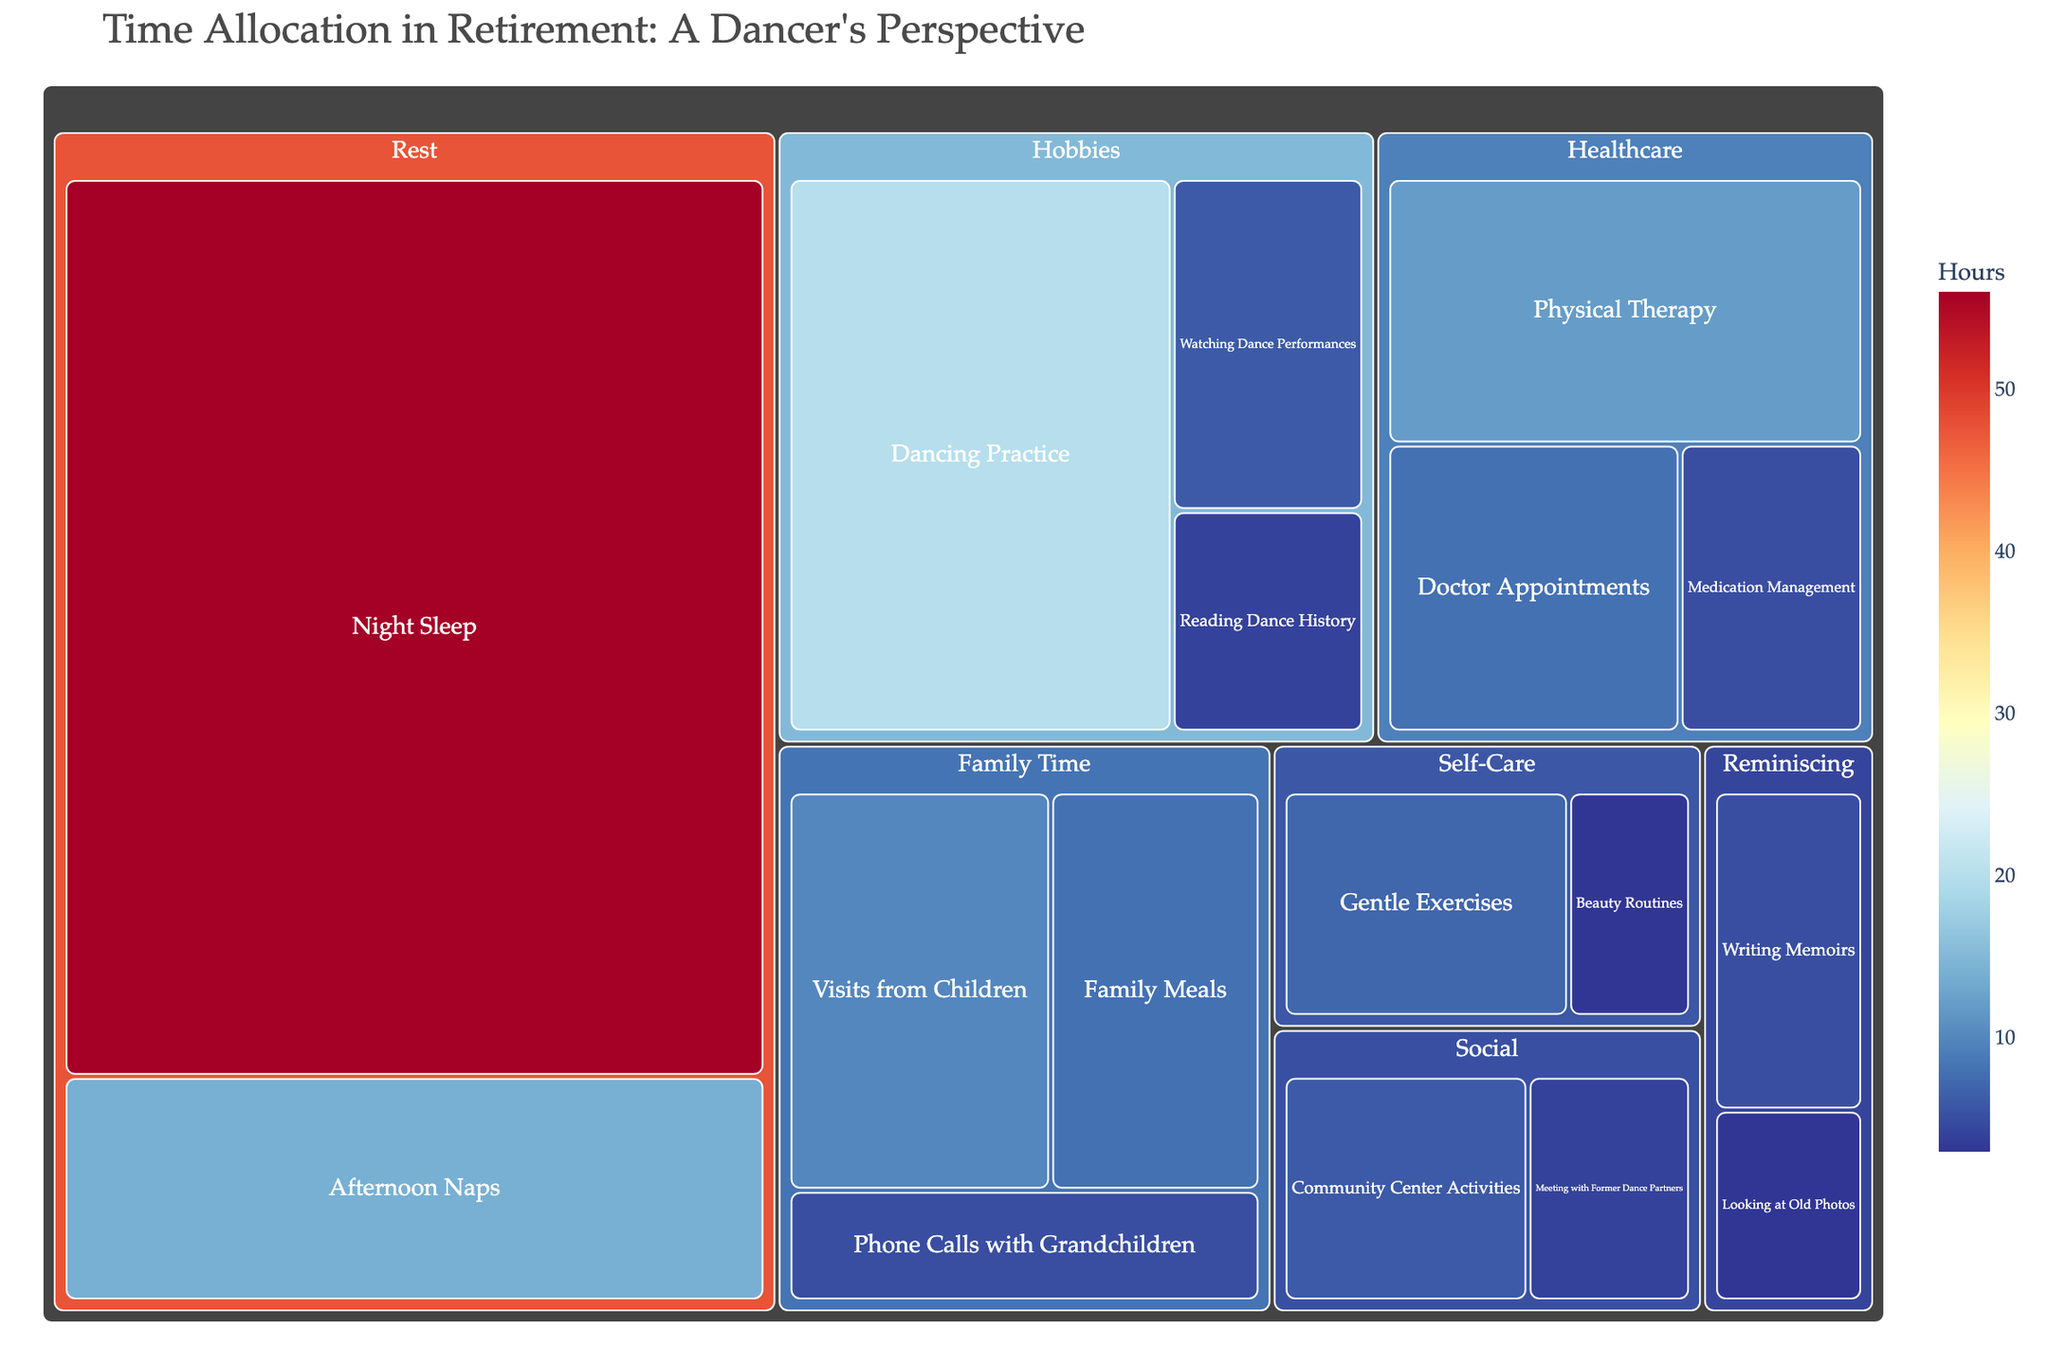What's the title of the figure? The title of the figure is provided at the top of the treemap.
Answer: Time Allocation in Retirement: A Dancer's Perspective Which subcategory under Healthcare has the highest hours? Check the Healthcare category and compare the hours of Doctor Appointments, Physical Therapy, and Medication Management.
Answer: Physical Therapy What is the total time spent on Hobbies? Sum the hours spent on Dancing Practice, Watching Dance Performances, and Reading Dance History. 20 + 6 + 4 = 30
Answer: 30 How does the time spent on Night Sleep compare to Family Meals? Compare the hours shown for Night Sleep and Family Meals to determine which is greater. Night Sleep has 56 hours and Family Meals has 8 hours.
Answer: Night Sleep is greater What is the average time spent on each activity in the Rest category? Sum the hours for Afternoon Naps and Night Sleep, then divide by the number of activities. (14 + 56) / 2 = 35
Answer: 35 Which category has the least amount of time allocated? Explain your reasoning. Compare the total hours for each category: Healthcare, Hobbies, Family Time, Rest, Reminiscing, Social, Self-Care and determine the smallest one.
Answer: Reminiscing with 8 hours How much more time is spent on Gentle Exercises compared to Beauty Routines? Subtract the hours for Beauty Routines from the hours for Gentle Exercises. 7 - 3 = 4
Answer: 4 What is the combined time spent on activities in Social and Self-Care categories? Sum the hours of Meeting with Former Dance Partners, Community Center Activities, Gentle Exercises, and Beauty Routines. 4 + 6 + 7 + 3 = 20
Answer: 20 Between Visits from Children and Phone Calls with Grandchildren, which one takes more time? Compare the hours shown for Visits from Children and Phone Calls with Grandchildren to find the greater one.
Answer: Visits from Children 